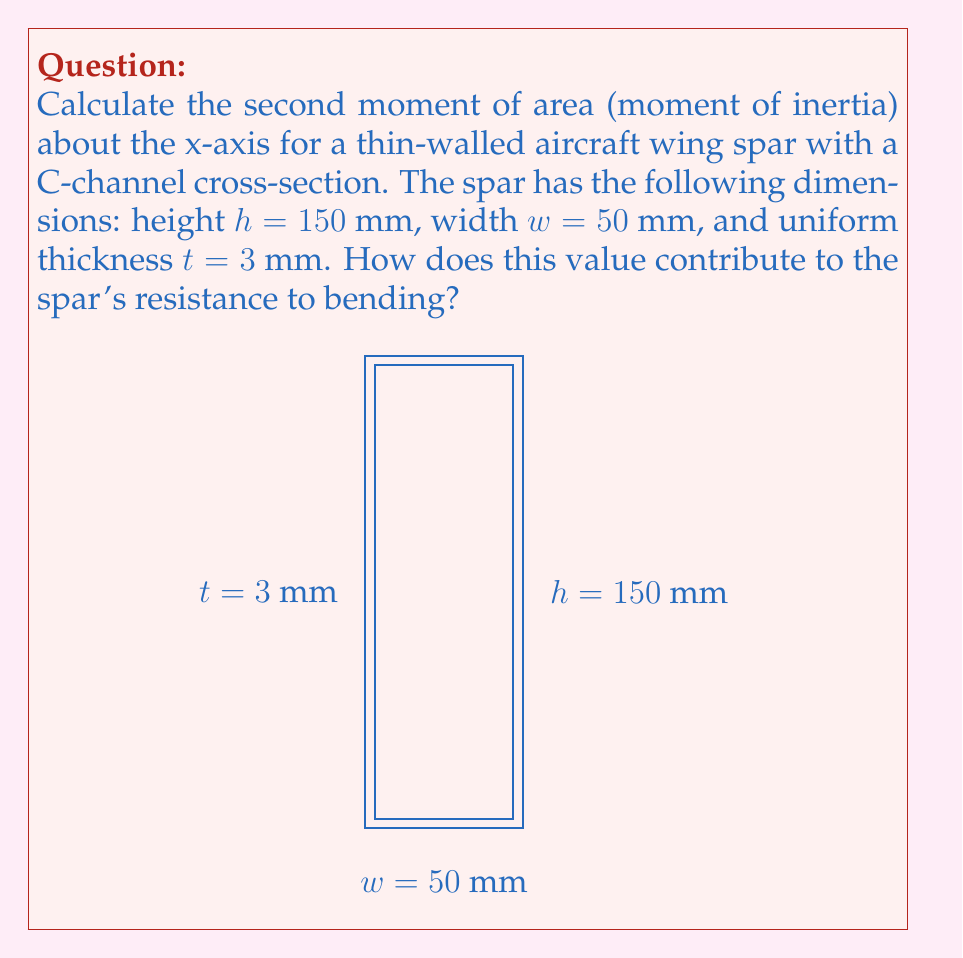Provide a solution to this math problem. To calculate the second moment of area (I_x) for this C-channel cross-section, we'll use the parallel axis theorem and divide the shape into three rectangles:

1. Two vertical flanges: 3 mm x 150 mm
2. One horizontal web: 44 mm x 3 mm

Step 1: Calculate I_x for each rectangle about its own centroidal axis:
For a rectangle: $I = \frac{1}{12}bh^3$

Vertical flanges: $I_{flange} = \frac{1}{12}(3)(150)^3 = 84,375$ mm⁴
Horizontal web: $I_{web} = \frac{1}{12}(44)(3)^3 = 99$ mm⁴

Step 2: Use the parallel axis theorem to find the moment of inertia of each part about the x-axis:
$I = I_{own} + Ad^2$, where A is the area and d is the distance from the centroid to the x-axis.

Left flange: $I_{left} = 84,375 + (3 \cdot 150) \cdot (25)^2 = 365,625$ mm⁴
Right flange: $I_{right} = 84,375 + (3 \cdot 150) \cdot (25)^2 = 365,625$ mm⁴
Web: $I_{web} = 99 + (44 \cdot 3) \cdot (73.5)^2 = 715,341$ mm⁴

Step 3: Sum all components:
$I_x = I_{left} + I_{right} + I_{web} = 365,625 + 365,625 + 715,341 = 1,446,591$ mm⁴

The high I_x value indicates strong resistance to bending about the x-axis. This is crucial for wing spars, which must withstand significant bending moments during flight. The C-channel shape efficiently distributes material away from the neutral axis, maximizing bending stiffness while minimizing weight.
Answer: $I_x = 1,446,591$ mm⁴ 